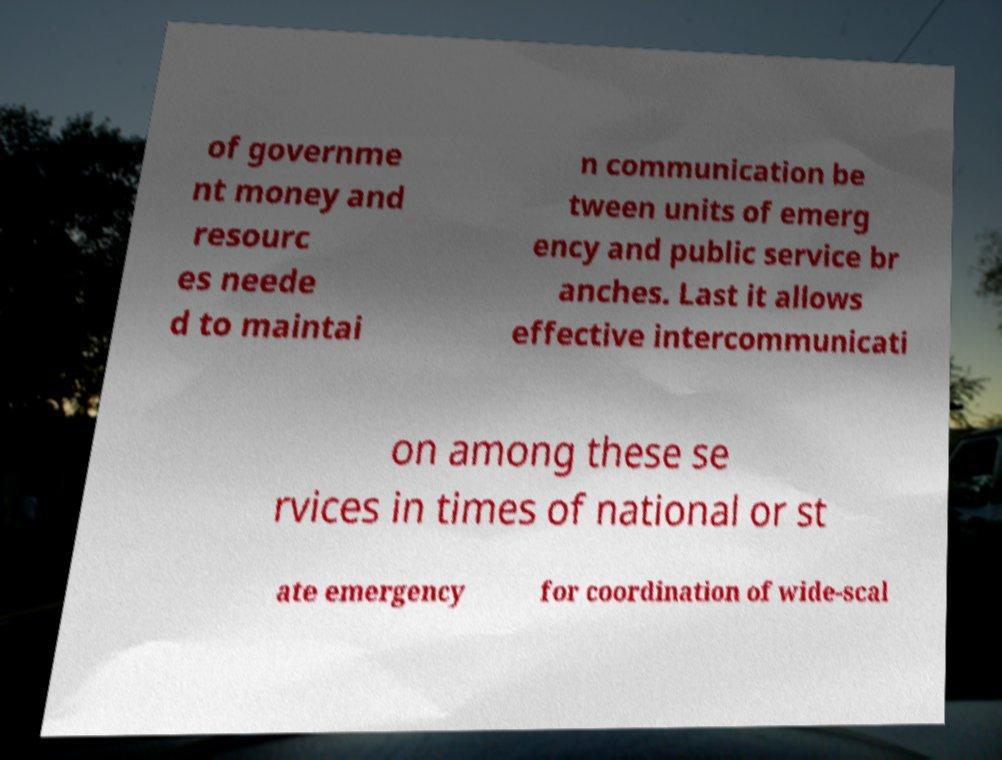Please read and relay the text visible in this image. What does it say? of governme nt money and resourc es neede d to maintai n communication be tween units of emerg ency and public service br anches. Last it allows effective intercommunicati on among these se rvices in times of national or st ate emergency for coordination of wide-scal 